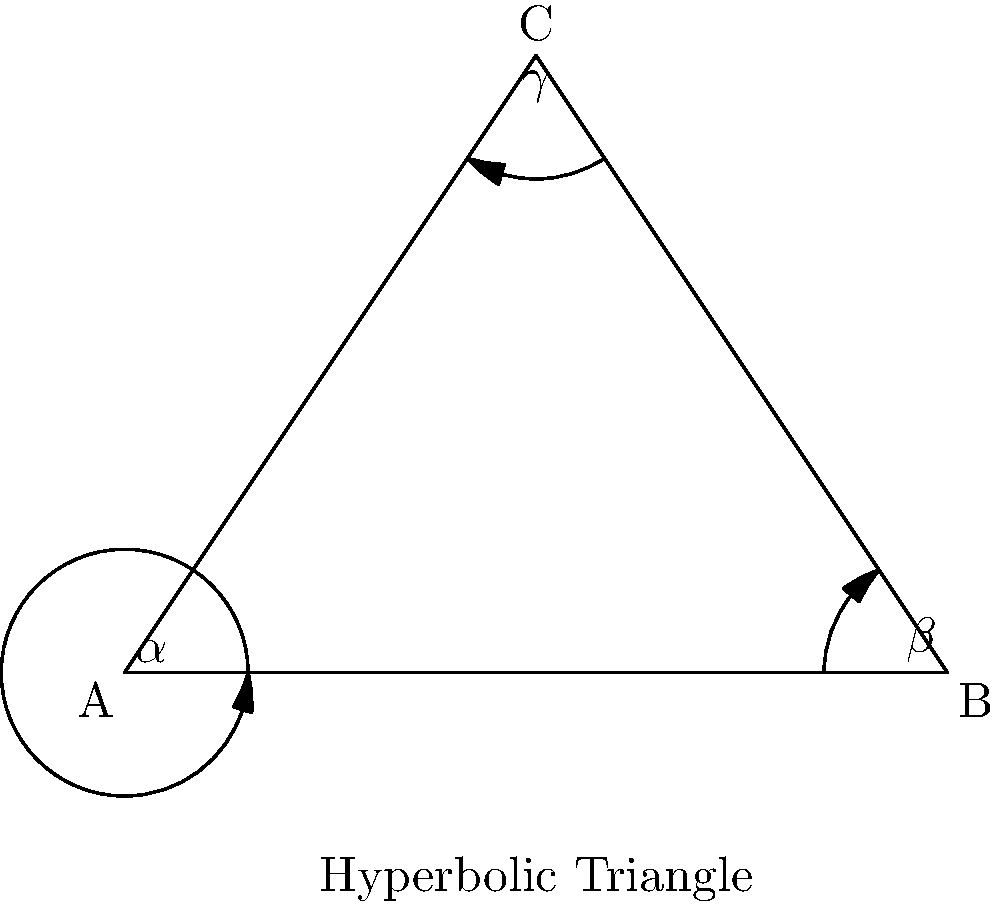In a hyperbolic triangle ABC, the angles are denoted as $\alpha$, $\beta$, and $\gamma$. How does the sum of these angles compare to that of a Euclidean triangle, and what implications does this have for the shape of hyperbolic space? To understand the sum of angles in a hyperbolic triangle:

1. In Euclidean geometry, the sum of angles in a triangle is always 180°.

2. In hyperbolic geometry, the sum of angles in a triangle is always less than 180°.

3. The difference between 180° and the sum of angles in a hyperbolic triangle is called the defect: $\delta = 180° - (\alpha + \beta + \gamma)$

4. This defect is directly proportional to the area of the triangle in hyperbolic space.

5. As the size of the hyperbolic triangle increases, the sum of its angles decreases, approaching 0° for very large triangles.

6. This property implies that hyperbolic space has negative curvature, unlike Euclidean space which is flat.

7. In the context of election monitoring, this concept could be used as an analogy for how the combined influence of multiple factors (represented by angles) in a voting district might not always add up as expected, leading to unexpected outcomes in election results.
Answer: Sum $< 180°$; implies negative curvature of space 